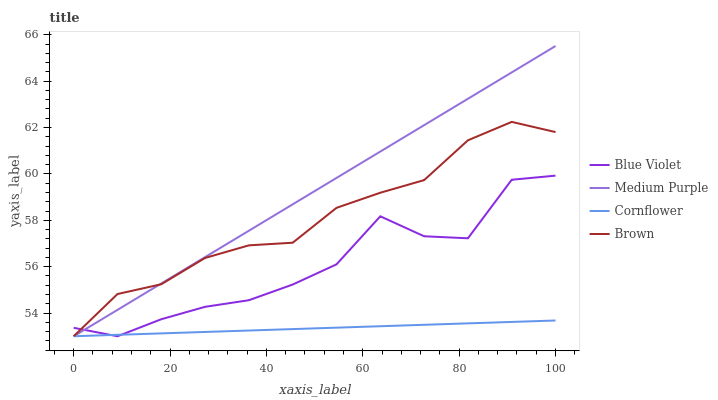Does Cornflower have the minimum area under the curve?
Answer yes or no. Yes. Does Medium Purple have the maximum area under the curve?
Answer yes or no. Yes. Does Blue Violet have the minimum area under the curve?
Answer yes or no. No. Does Blue Violet have the maximum area under the curve?
Answer yes or no. No. Is Cornflower the smoothest?
Answer yes or no. Yes. Is Blue Violet the roughest?
Answer yes or no. Yes. Is Blue Violet the smoothest?
Answer yes or no. No. Is Cornflower the roughest?
Answer yes or no. No. Does Medium Purple have the highest value?
Answer yes or no. Yes. Does Blue Violet have the highest value?
Answer yes or no. No. Does Blue Violet intersect Medium Purple?
Answer yes or no. Yes. Is Blue Violet less than Medium Purple?
Answer yes or no. No. Is Blue Violet greater than Medium Purple?
Answer yes or no. No. 